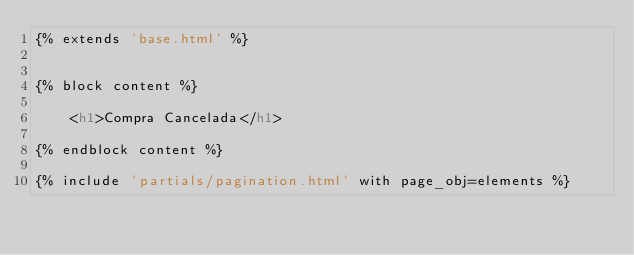Convert code to text. <code><loc_0><loc_0><loc_500><loc_500><_HTML_>{% extends 'base.html' %}


{% block content %}

    <h1>Compra Cancelada</h1>

{% endblock content %}

{% include 'partials/pagination.html' with page_obj=elements %}</code> 